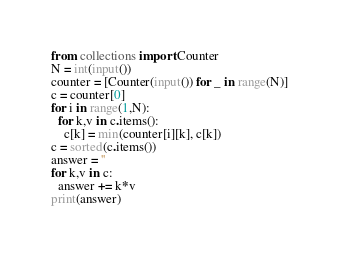<code> <loc_0><loc_0><loc_500><loc_500><_Python_>from collections import Counter
N = int(input())
counter = [Counter(input()) for _ in range(N)]
c = counter[0]
for i in range(1,N):
  for k,v in c.items():
    c[k] = min(counter[i][k], c[k])
c = sorted(c.items())
answer = ''
for k,v in c:
  answer += k*v
print(answer)
</code> 